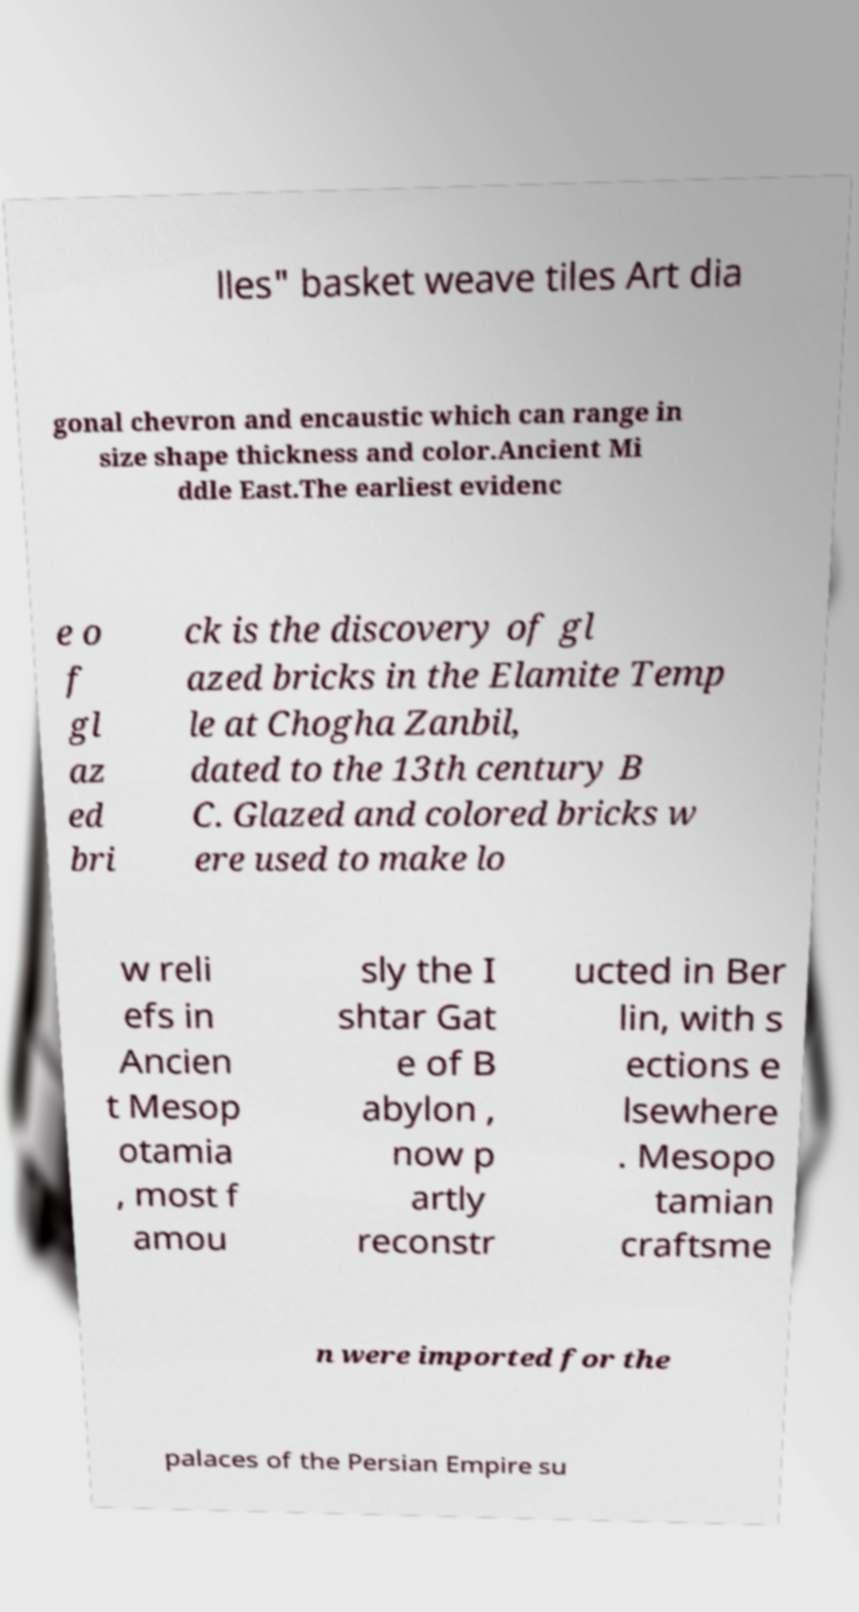Can you accurately transcribe the text from the provided image for me? lles" basket weave tiles Art dia gonal chevron and encaustic which can range in size shape thickness and color.Ancient Mi ddle East.The earliest evidenc e o f gl az ed bri ck is the discovery of gl azed bricks in the Elamite Temp le at Chogha Zanbil, dated to the 13th century B C. Glazed and colored bricks w ere used to make lo w reli efs in Ancien t Mesop otamia , most f amou sly the I shtar Gat e of B abylon , now p artly reconstr ucted in Ber lin, with s ections e lsewhere . Mesopo tamian craftsme n were imported for the palaces of the Persian Empire su 